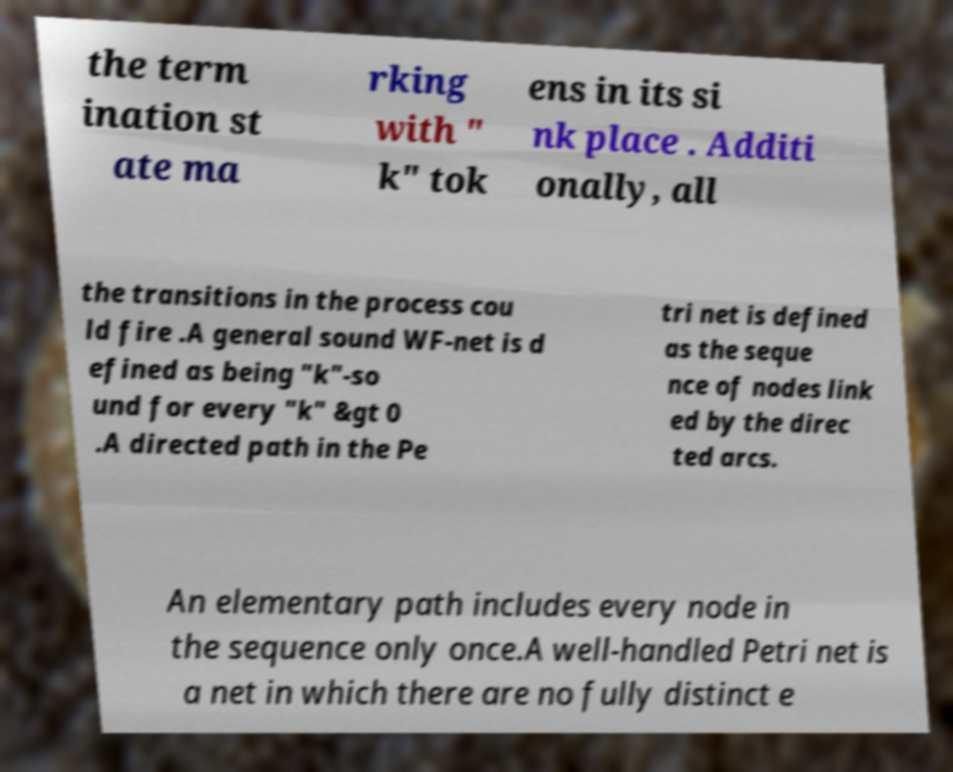For documentation purposes, I need the text within this image transcribed. Could you provide that? the term ination st ate ma rking with " k" tok ens in its si nk place . Additi onally, all the transitions in the process cou ld fire .A general sound WF-net is d efined as being "k"-so und for every "k" &gt 0 .A directed path in the Pe tri net is defined as the seque nce of nodes link ed by the direc ted arcs. An elementary path includes every node in the sequence only once.A well-handled Petri net is a net in which there are no fully distinct e 